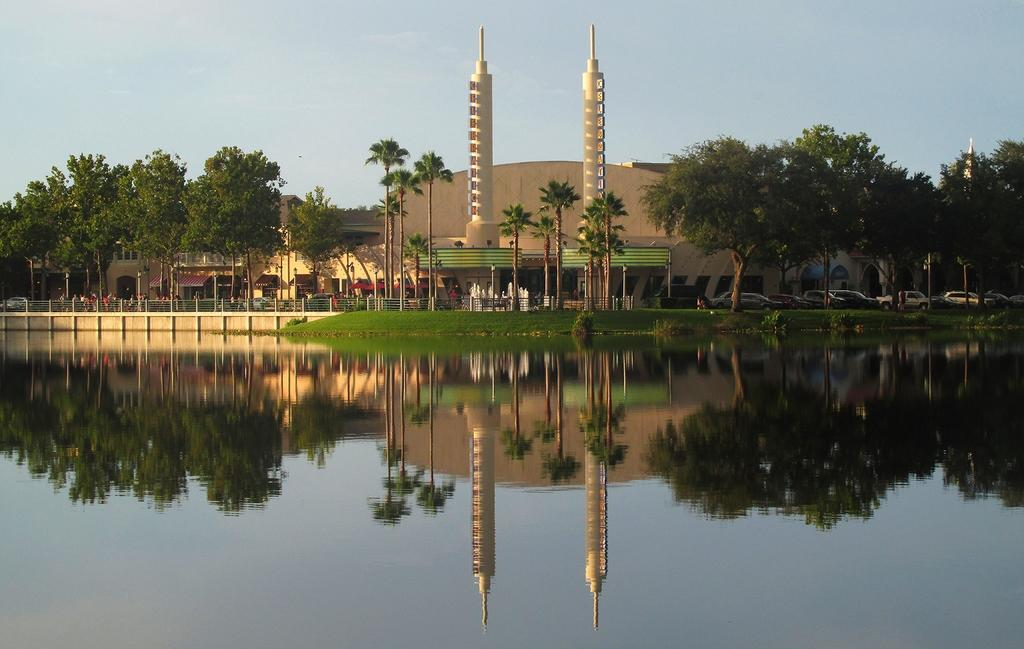What can be seen in the image? Water is visible in the image. What is visible in the background of the image? There are buildings, trees, and vehicles in the background of the image. What is the color of the sky in the image? The sky is blue in color. What type of advertisement can be seen on the water in the image? There is no advertisement present on the water in the image. What type of cabbage is being grown in the water in the image? There is no cabbage present in the image, and the water is not a growing medium for plants. 